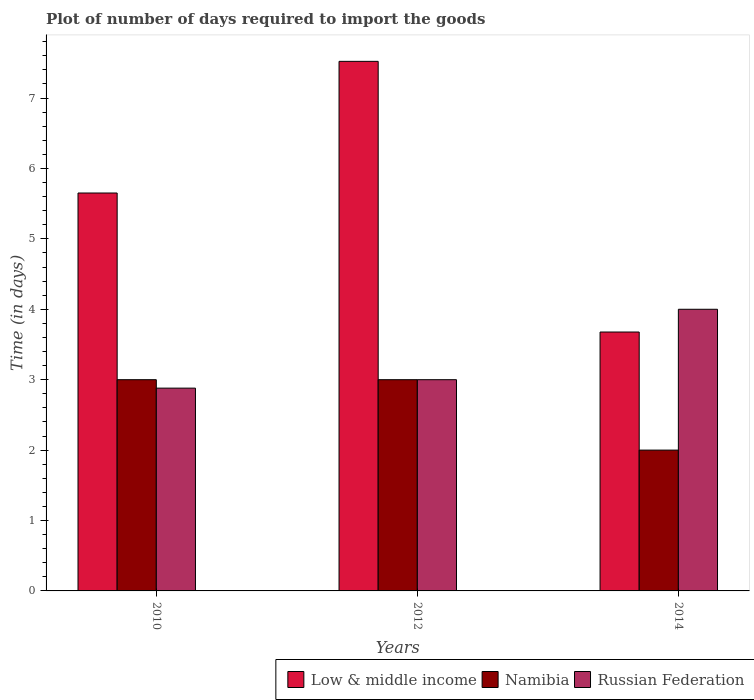How many groups of bars are there?
Keep it short and to the point. 3. Are the number of bars per tick equal to the number of legend labels?
Provide a succinct answer. Yes. Are the number of bars on each tick of the X-axis equal?
Provide a succinct answer. Yes. How many bars are there on the 2nd tick from the right?
Your answer should be compact. 3. What is the time required to import goods in Russian Federation in 2012?
Make the answer very short. 3. Across all years, what is the maximum time required to import goods in Low & middle income?
Your response must be concise. 7.52. Across all years, what is the minimum time required to import goods in Russian Federation?
Your answer should be compact. 2.88. What is the total time required to import goods in Low & middle income in the graph?
Provide a succinct answer. 16.85. What is the difference between the time required to import goods in Low & middle income in 2010 and that in 2014?
Make the answer very short. 1.97. What is the difference between the time required to import goods in Namibia in 2010 and the time required to import goods in Russian Federation in 2012?
Ensure brevity in your answer.  0. What is the average time required to import goods in Low & middle income per year?
Keep it short and to the point. 5.62. In the year 2010, what is the difference between the time required to import goods in Namibia and time required to import goods in Low & middle income?
Offer a terse response. -2.65. What is the difference between the highest and the second highest time required to import goods in Namibia?
Your response must be concise. 0. What is the difference between the highest and the lowest time required to import goods in Namibia?
Provide a succinct answer. 1. Is it the case that in every year, the sum of the time required to import goods in Russian Federation and time required to import goods in Low & middle income is greater than the time required to import goods in Namibia?
Give a very brief answer. Yes. Are all the bars in the graph horizontal?
Provide a short and direct response. No. How are the legend labels stacked?
Offer a very short reply. Horizontal. What is the title of the graph?
Your answer should be compact. Plot of number of days required to import the goods. What is the label or title of the X-axis?
Offer a terse response. Years. What is the label or title of the Y-axis?
Ensure brevity in your answer.  Time (in days). What is the Time (in days) in Low & middle income in 2010?
Your answer should be compact. 5.65. What is the Time (in days) of Russian Federation in 2010?
Provide a short and direct response. 2.88. What is the Time (in days) of Low & middle income in 2012?
Provide a succinct answer. 7.52. What is the Time (in days) of Namibia in 2012?
Provide a short and direct response. 3. What is the Time (in days) of Russian Federation in 2012?
Provide a succinct answer. 3. What is the Time (in days) in Low & middle income in 2014?
Provide a succinct answer. 3.68. What is the Time (in days) of Russian Federation in 2014?
Your answer should be very brief. 4. Across all years, what is the maximum Time (in days) in Low & middle income?
Your answer should be compact. 7.52. Across all years, what is the minimum Time (in days) in Low & middle income?
Offer a very short reply. 3.68. Across all years, what is the minimum Time (in days) of Russian Federation?
Offer a very short reply. 2.88. What is the total Time (in days) in Low & middle income in the graph?
Your answer should be very brief. 16.85. What is the total Time (in days) in Russian Federation in the graph?
Give a very brief answer. 9.88. What is the difference between the Time (in days) in Low & middle income in 2010 and that in 2012?
Give a very brief answer. -1.87. What is the difference between the Time (in days) in Namibia in 2010 and that in 2012?
Give a very brief answer. 0. What is the difference between the Time (in days) in Russian Federation in 2010 and that in 2012?
Offer a terse response. -0.12. What is the difference between the Time (in days) in Low & middle income in 2010 and that in 2014?
Your answer should be very brief. 1.97. What is the difference between the Time (in days) of Russian Federation in 2010 and that in 2014?
Your answer should be very brief. -1.12. What is the difference between the Time (in days) in Low & middle income in 2012 and that in 2014?
Offer a terse response. 3.84. What is the difference between the Time (in days) of Low & middle income in 2010 and the Time (in days) of Namibia in 2012?
Offer a very short reply. 2.65. What is the difference between the Time (in days) in Low & middle income in 2010 and the Time (in days) in Russian Federation in 2012?
Keep it short and to the point. 2.65. What is the difference between the Time (in days) of Namibia in 2010 and the Time (in days) of Russian Federation in 2012?
Offer a terse response. 0. What is the difference between the Time (in days) of Low & middle income in 2010 and the Time (in days) of Namibia in 2014?
Make the answer very short. 3.65. What is the difference between the Time (in days) in Low & middle income in 2010 and the Time (in days) in Russian Federation in 2014?
Offer a terse response. 1.65. What is the difference between the Time (in days) of Namibia in 2010 and the Time (in days) of Russian Federation in 2014?
Keep it short and to the point. -1. What is the difference between the Time (in days) in Low & middle income in 2012 and the Time (in days) in Namibia in 2014?
Ensure brevity in your answer.  5.52. What is the difference between the Time (in days) of Low & middle income in 2012 and the Time (in days) of Russian Federation in 2014?
Your answer should be compact. 3.52. What is the difference between the Time (in days) in Namibia in 2012 and the Time (in days) in Russian Federation in 2014?
Your response must be concise. -1. What is the average Time (in days) of Low & middle income per year?
Offer a terse response. 5.62. What is the average Time (in days) of Namibia per year?
Your response must be concise. 2.67. What is the average Time (in days) of Russian Federation per year?
Offer a very short reply. 3.29. In the year 2010, what is the difference between the Time (in days) in Low & middle income and Time (in days) in Namibia?
Give a very brief answer. 2.65. In the year 2010, what is the difference between the Time (in days) in Low & middle income and Time (in days) in Russian Federation?
Give a very brief answer. 2.77. In the year 2010, what is the difference between the Time (in days) of Namibia and Time (in days) of Russian Federation?
Keep it short and to the point. 0.12. In the year 2012, what is the difference between the Time (in days) of Low & middle income and Time (in days) of Namibia?
Offer a very short reply. 4.52. In the year 2012, what is the difference between the Time (in days) of Low & middle income and Time (in days) of Russian Federation?
Ensure brevity in your answer.  4.52. In the year 2014, what is the difference between the Time (in days) of Low & middle income and Time (in days) of Namibia?
Provide a short and direct response. 1.68. In the year 2014, what is the difference between the Time (in days) in Low & middle income and Time (in days) in Russian Federation?
Offer a very short reply. -0.32. What is the ratio of the Time (in days) of Low & middle income in 2010 to that in 2012?
Provide a succinct answer. 0.75. What is the ratio of the Time (in days) in Namibia in 2010 to that in 2012?
Provide a succinct answer. 1. What is the ratio of the Time (in days) in Russian Federation in 2010 to that in 2012?
Provide a short and direct response. 0.96. What is the ratio of the Time (in days) in Low & middle income in 2010 to that in 2014?
Make the answer very short. 1.54. What is the ratio of the Time (in days) in Namibia in 2010 to that in 2014?
Offer a very short reply. 1.5. What is the ratio of the Time (in days) of Russian Federation in 2010 to that in 2014?
Offer a terse response. 0.72. What is the ratio of the Time (in days) in Low & middle income in 2012 to that in 2014?
Ensure brevity in your answer.  2.05. What is the difference between the highest and the second highest Time (in days) of Low & middle income?
Offer a very short reply. 1.87. What is the difference between the highest and the second highest Time (in days) of Russian Federation?
Offer a terse response. 1. What is the difference between the highest and the lowest Time (in days) in Low & middle income?
Offer a very short reply. 3.84. What is the difference between the highest and the lowest Time (in days) in Namibia?
Keep it short and to the point. 1. What is the difference between the highest and the lowest Time (in days) in Russian Federation?
Your answer should be very brief. 1.12. 